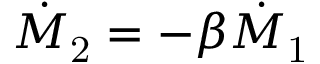<formula> <loc_0><loc_0><loc_500><loc_500>\dot { M } _ { 2 } = - \beta \dot { M } _ { 1 }</formula> 